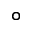<formula> <loc_0><loc_0><loc_500><loc_500>^ { \circ }</formula> 